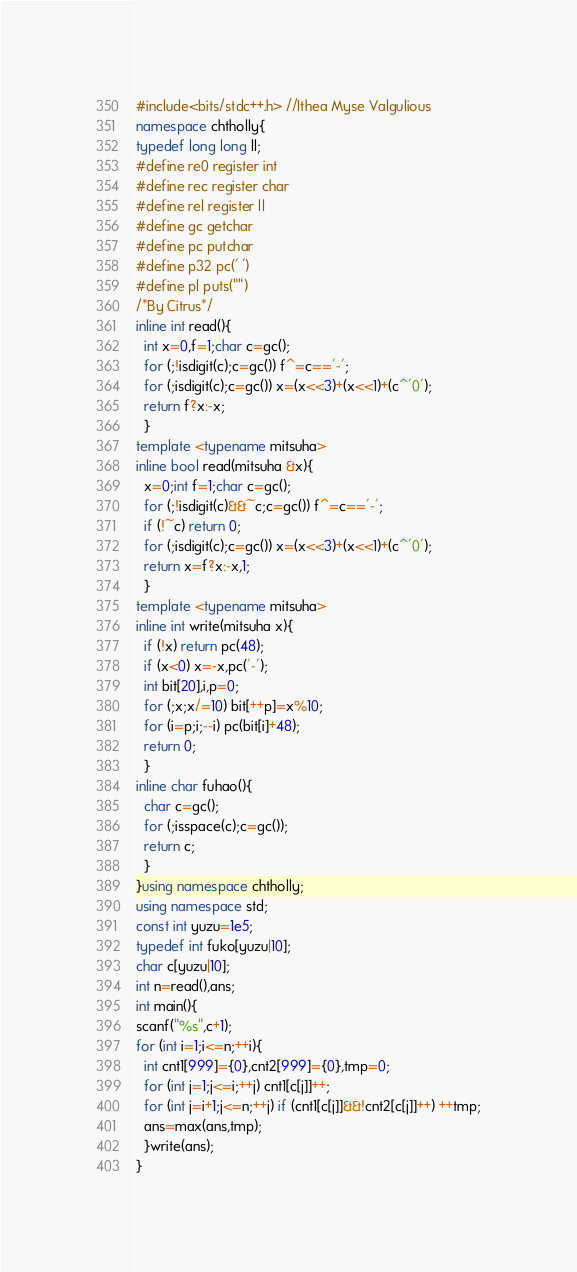Convert code to text. <code><loc_0><loc_0><loc_500><loc_500><_C++_>#include<bits/stdc++.h> //Ithea Myse Valgulious
namespace chtholly{
typedef long long ll;
#define re0 register int
#define rec register char
#define rel register ll
#define gc getchar
#define pc putchar
#define p32 pc(' ')
#define pl puts("")
/*By Citrus*/
inline int read(){
  int x=0,f=1;char c=gc();
  for (;!isdigit(c);c=gc()) f^=c=='-';
  for (;isdigit(c);c=gc()) x=(x<<3)+(x<<1)+(c^'0');
  return f?x:-x;
  }
template <typename mitsuha>
inline bool read(mitsuha &x){
  x=0;int f=1;char c=gc();
  for (;!isdigit(c)&&~c;c=gc()) f^=c=='-';
  if (!~c) return 0;
  for (;isdigit(c);c=gc()) x=(x<<3)+(x<<1)+(c^'0');
  return x=f?x:-x,1;
  }
template <typename mitsuha>
inline int write(mitsuha x){
  if (!x) return pc(48);
  if (x<0) x=-x,pc('-');
  int bit[20],i,p=0;
  for (;x;x/=10) bit[++p]=x%10;
  for (i=p;i;--i) pc(bit[i]+48);
  return 0;
  }
inline char fuhao(){
  char c=gc();
  for (;isspace(c);c=gc());
  return c;
  }
}using namespace chtholly;
using namespace std;
const int yuzu=1e5;
typedef int fuko[yuzu|10];
char c[yuzu|10];
int n=read(),ans;
int main(){
scanf("%s",c+1);
for (int i=1;i<=n;++i){
  int cnt1[999]={0},cnt2[999]={0},tmp=0;
  for (int j=1;j<=i;++j) cnt1[c[j]]++;
  for (int j=i+1;j<=n;++j) if (cnt1[c[j]]&&!cnt2[c[j]]++) ++tmp;
  ans=max(ans,tmp);  
  }write(ans);
}</code> 